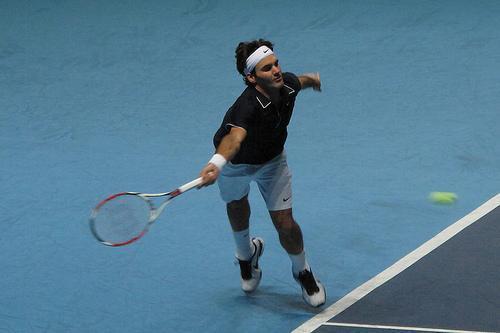How many balls are coming toward the man playing tennis?
Give a very brief answer. 1. How many tennis rackets in the photo?
Give a very brief answer. 1. How many people are in the photo?
Give a very brief answer. 1. 